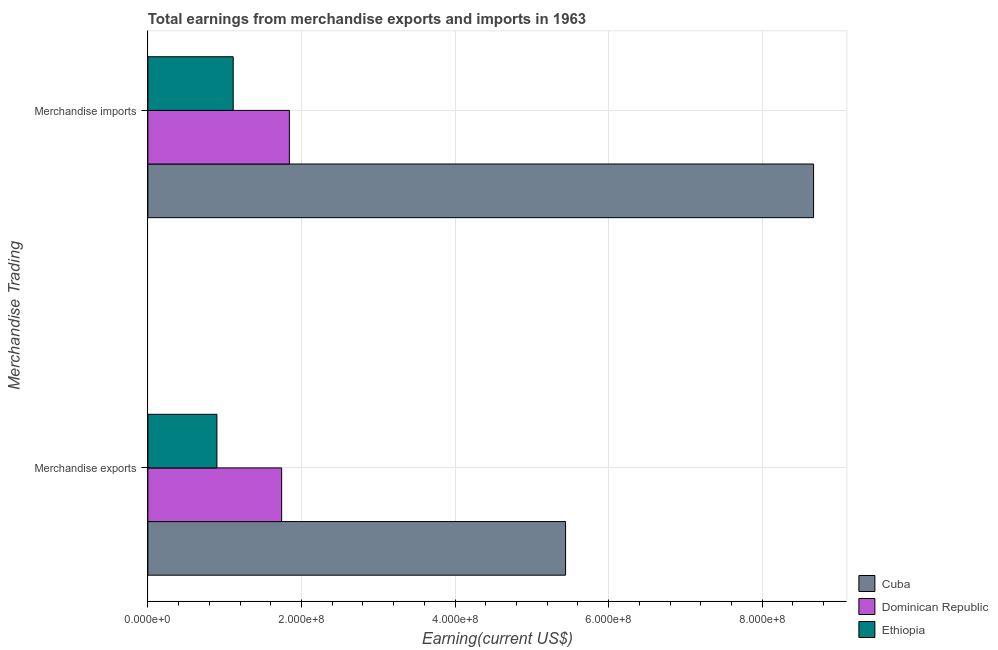How many groups of bars are there?
Your answer should be very brief. 2. Are the number of bars per tick equal to the number of legend labels?
Make the answer very short. Yes. Are the number of bars on each tick of the Y-axis equal?
Your answer should be very brief. Yes. How many bars are there on the 2nd tick from the bottom?
Your answer should be very brief. 3. What is the earnings from merchandise exports in Ethiopia?
Your response must be concise. 8.99e+07. Across all countries, what is the maximum earnings from merchandise exports?
Make the answer very short. 5.44e+08. Across all countries, what is the minimum earnings from merchandise exports?
Ensure brevity in your answer.  8.99e+07. In which country was the earnings from merchandise imports maximum?
Your response must be concise. Cuba. In which country was the earnings from merchandise imports minimum?
Provide a succinct answer. Ethiopia. What is the total earnings from merchandise imports in the graph?
Ensure brevity in your answer.  1.16e+09. What is the difference between the earnings from merchandise exports in Dominican Republic and that in Ethiopia?
Provide a succinct answer. 8.43e+07. What is the difference between the earnings from merchandise exports in Dominican Republic and the earnings from merchandise imports in Ethiopia?
Make the answer very short. 6.31e+07. What is the average earnings from merchandise exports per country?
Provide a succinct answer. 2.69e+08. What is the difference between the earnings from merchandise exports and earnings from merchandise imports in Cuba?
Ensure brevity in your answer.  -3.23e+08. In how many countries, is the earnings from merchandise exports greater than 400000000 US$?
Give a very brief answer. 1. What is the ratio of the earnings from merchandise exports in Dominican Republic to that in Cuba?
Keep it short and to the point. 0.32. In how many countries, is the earnings from merchandise exports greater than the average earnings from merchandise exports taken over all countries?
Offer a terse response. 1. What does the 3rd bar from the top in Merchandise exports represents?
Offer a terse response. Cuba. What does the 3rd bar from the bottom in Merchandise imports represents?
Offer a very short reply. Ethiopia. Are all the bars in the graph horizontal?
Your answer should be very brief. Yes. Are the values on the major ticks of X-axis written in scientific E-notation?
Offer a very short reply. Yes. Does the graph contain any zero values?
Your answer should be very brief. No. Does the graph contain grids?
Ensure brevity in your answer.  Yes. How many legend labels are there?
Give a very brief answer. 3. What is the title of the graph?
Make the answer very short. Total earnings from merchandise exports and imports in 1963. What is the label or title of the X-axis?
Give a very brief answer. Earning(current US$). What is the label or title of the Y-axis?
Make the answer very short. Merchandise Trading. What is the Earning(current US$) of Cuba in Merchandise exports?
Offer a terse response. 5.44e+08. What is the Earning(current US$) in Dominican Republic in Merchandise exports?
Your response must be concise. 1.74e+08. What is the Earning(current US$) of Ethiopia in Merchandise exports?
Provide a short and direct response. 8.99e+07. What is the Earning(current US$) of Cuba in Merchandise imports?
Keep it short and to the point. 8.67e+08. What is the Earning(current US$) of Dominican Republic in Merchandise imports?
Your answer should be very brief. 1.84e+08. What is the Earning(current US$) in Ethiopia in Merchandise imports?
Offer a terse response. 1.11e+08. Across all Merchandise Trading, what is the maximum Earning(current US$) of Cuba?
Provide a short and direct response. 8.67e+08. Across all Merchandise Trading, what is the maximum Earning(current US$) of Dominican Republic?
Give a very brief answer. 1.84e+08. Across all Merchandise Trading, what is the maximum Earning(current US$) of Ethiopia?
Make the answer very short. 1.11e+08. Across all Merchandise Trading, what is the minimum Earning(current US$) of Cuba?
Make the answer very short. 5.44e+08. Across all Merchandise Trading, what is the minimum Earning(current US$) of Dominican Republic?
Provide a short and direct response. 1.74e+08. Across all Merchandise Trading, what is the minimum Earning(current US$) in Ethiopia?
Make the answer very short. 8.99e+07. What is the total Earning(current US$) in Cuba in the graph?
Provide a succinct answer. 1.41e+09. What is the total Earning(current US$) of Dominican Republic in the graph?
Offer a very short reply. 3.59e+08. What is the total Earning(current US$) in Ethiopia in the graph?
Give a very brief answer. 2.01e+08. What is the difference between the Earning(current US$) of Cuba in Merchandise exports and that in Merchandise imports?
Provide a succinct answer. -3.23e+08. What is the difference between the Earning(current US$) in Dominican Republic in Merchandise exports and that in Merchandise imports?
Your response must be concise. -1.01e+07. What is the difference between the Earning(current US$) in Ethiopia in Merchandise exports and that in Merchandise imports?
Your response must be concise. -2.12e+07. What is the difference between the Earning(current US$) in Cuba in Merchandise exports and the Earning(current US$) in Dominican Republic in Merchandise imports?
Give a very brief answer. 3.60e+08. What is the difference between the Earning(current US$) in Cuba in Merchandise exports and the Earning(current US$) in Ethiopia in Merchandise imports?
Your answer should be compact. 4.33e+08. What is the difference between the Earning(current US$) in Dominican Republic in Merchandise exports and the Earning(current US$) in Ethiopia in Merchandise imports?
Give a very brief answer. 6.31e+07. What is the average Earning(current US$) in Cuba per Merchandise Trading?
Your response must be concise. 7.06e+08. What is the average Earning(current US$) of Dominican Republic per Merchandise Trading?
Provide a short and direct response. 1.79e+08. What is the average Earning(current US$) in Ethiopia per Merchandise Trading?
Provide a succinct answer. 1.01e+08. What is the difference between the Earning(current US$) of Cuba and Earning(current US$) of Dominican Republic in Merchandise exports?
Provide a succinct answer. 3.70e+08. What is the difference between the Earning(current US$) of Cuba and Earning(current US$) of Ethiopia in Merchandise exports?
Give a very brief answer. 4.54e+08. What is the difference between the Earning(current US$) of Dominican Republic and Earning(current US$) of Ethiopia in Merchandise exports?
Give a very brief answer. 8.43e+07. What is the difference between the Earning(current US$) of Cuba and Earning(current US$) of Dominican Republic in Merchandise imports?
Your response must be concise. 6.83e+08. What is the difference between the Earning(current US$) in Cuba and Earning(current US$) in Ethiopia in Merchandise imports?
Offer a terse response. 7.56e+08. What is the difference between the Earning(current US$) of Dominican Republic and Earning(current US$) of Ethiopia in Merchandise imports?
Give a very brief answer. 7.32e+07. What is the ratio of the Earning(current US$) of Cuba in Merchandise exports to that in Merchandise imports?
Provide a succinct answer. 0.63. What is the ratio of the Earning(current US$) in Dominican Republic in Merchandise exports to that in Merchandise imports?
Give a very brief answer. 0.95. What is the ratio of the Earning(current US$) of Ethiopia in Merchandise exports to that in Merchandise imports?
Keep it short and to the point. 0.81. What is the difference between the highest and the second highest Earning(current US$) in Cuba?
Your answer should be compact. 3.23e+08. What is the difference between the highest and the second highest Earning(current US$) of Dominican Republic?
Provide a succinct answer. 1.01e+07. What is the difference between the highest and the second highest Earning(current US$) in Ethiopia?
Give a very brief answer. 2.12e+07. What is the difference between the highest and the lowest Earning(current US$) of Cuba?
Your response must be concise. 3.23e+08. What is the difference between the highest and the lowest Earning(current US$) of Dominican Republic?
Make the answer very short. 1.01e+07. What is the difference between the highest and the lowest Earning(current US$) in Ethiopia?
Make the answer very short. 2.12e+07. 